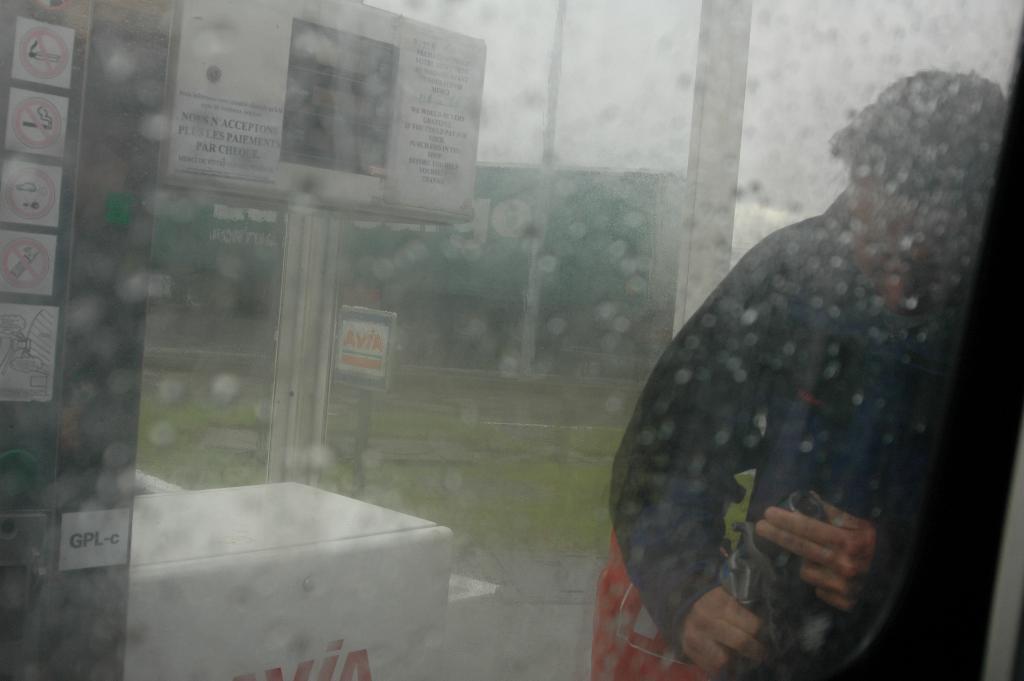How would you summarize this image in a sentence or two? On the right there is a man who is wearing hoodie and bag. He is holding an umbrella. On the left we can see poster of smoking. Here we can see sign boards and banners. In the back there is a shed. Here we can see grass. On the top there is a sky. On the glass we can see water drops. 